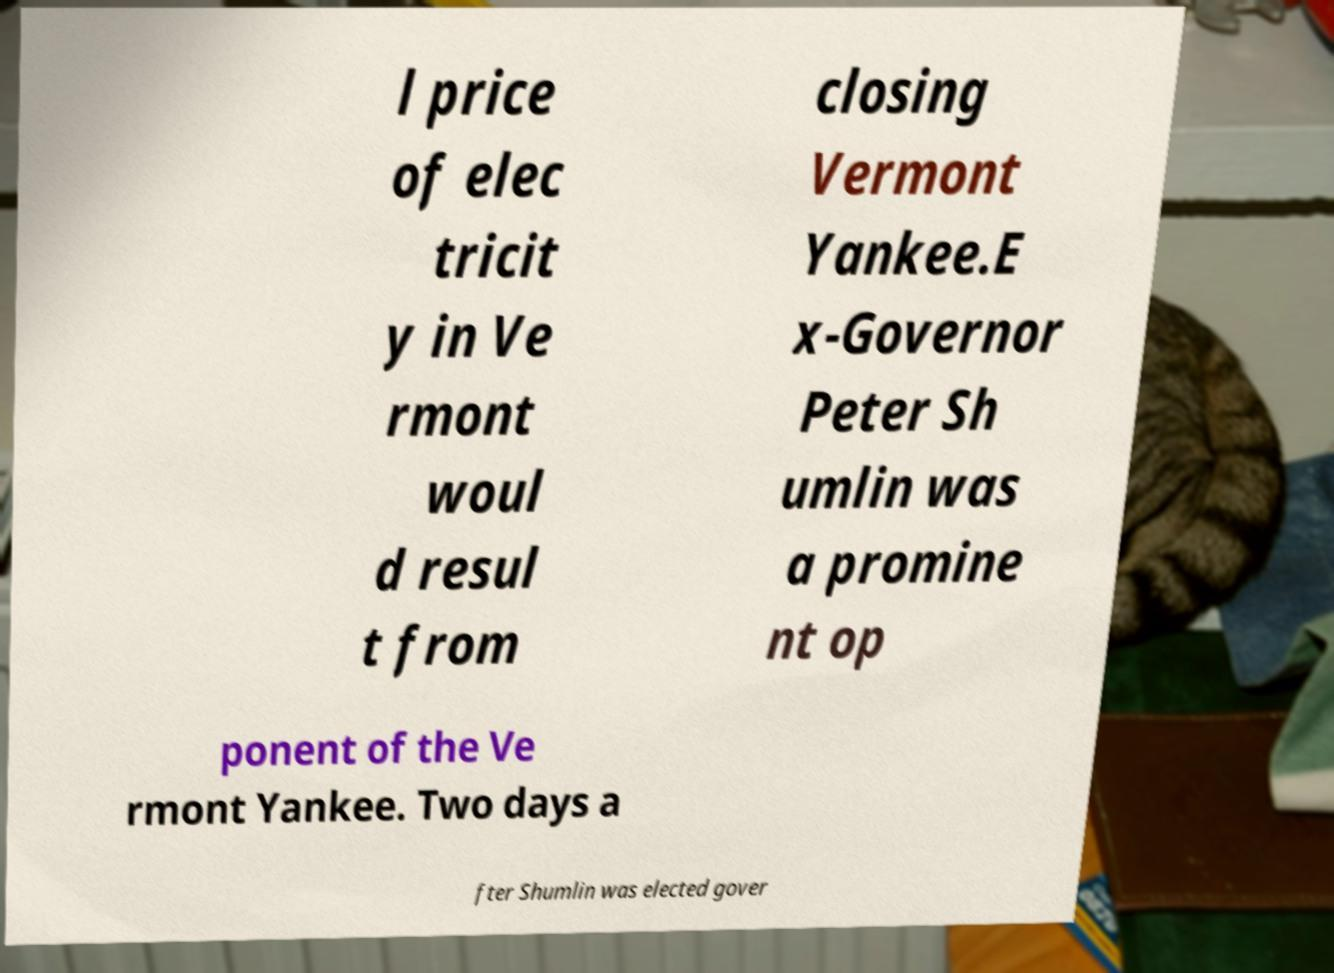Could you assist in decoding the text presented in this image and type it out clearly? l price of elec tricit y in Ve rmont woul d resul t from closing Vermont Yankee.E x-Governor Peter Sh umlin was a promine nt op ponent of the Ve rmont Yankee. Two days a fter Shumlin was elected gover 